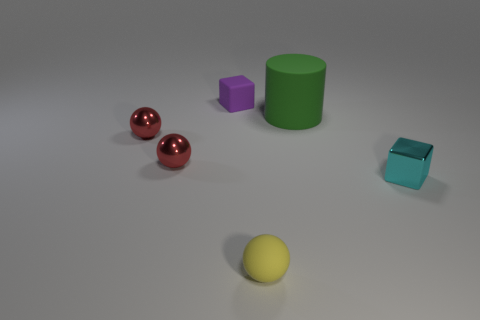Add 1 large gray things. How many objects exist? 7 Subtract all cylinders. How many objects are left? 5 Subtract all metallic balls. Subtract all small purple rubber objects. How many objects are left? 3 Add 6 small yellow spheres. How many small yellow spheres are left? 7 Add 4 metallic things. How many metallic things exist? 7 Subtract 0 blue blocks. How many objects are left? 6 